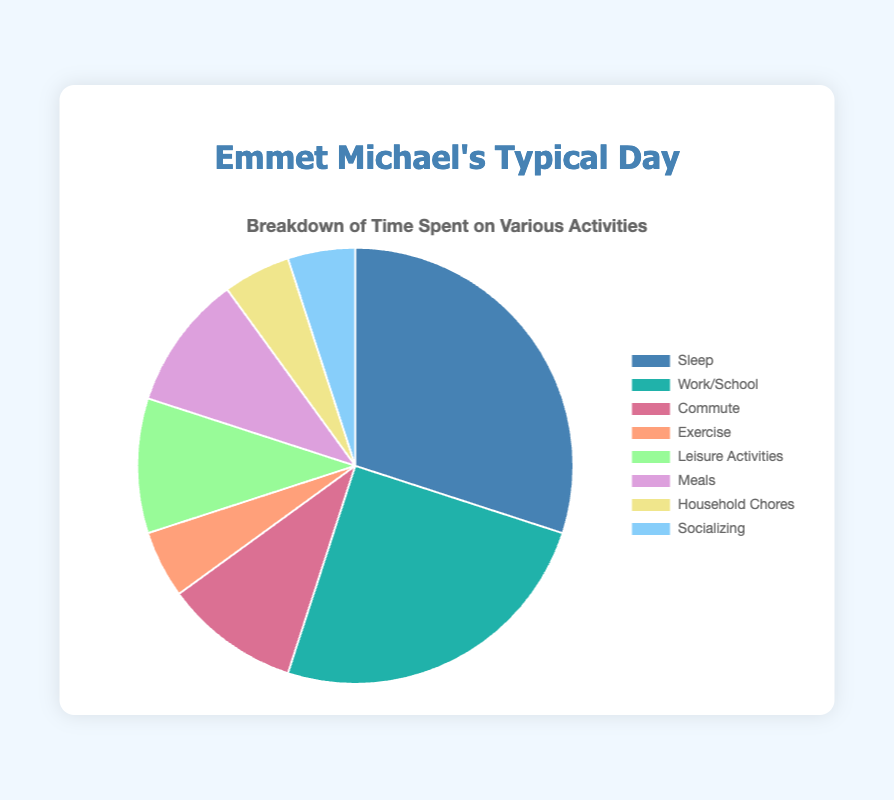What activity takes up the most time in a typical day? By viewing the chart, the largest segment represents "Sleep", implying it takes up the most time.
Answer: Sleep Which activities each consume 5% of the time? The chart's smallest segments, labeled "Exercise", "Household Chores", and "Socializing", each take up 5% of the time.
Answer: Exercise, Household Chores, Socializing How much more time is spent on Work/School compared to Leisure Activities? From the chart, Work/School is 25% and Leisure Activities is 10%. The difference is 25% - 10% = 15%.
Answer: 15% What fraction of the day is spent on Meals and Commute combined? Meals (10%) + Commute (10%) sum up to 20%.
Answer: 20% Which color segment represents the least amount of time spent on an activity? By observing the chart, the smallest segments (5%) have colors like #ffa07a for Exercise, #dde0dd for Household Chores, and #87cefa for Socializing.
Answer: Light Salmon (Exercise), Light Violet (Household Chores), Light Sky Blue (Socializing) 